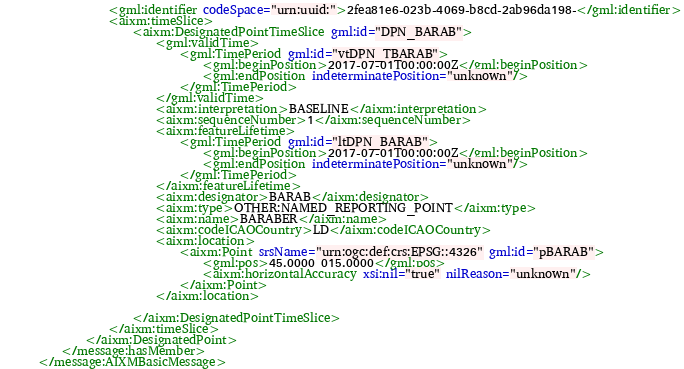Convert code to text. <code><loc_0><loc_0><loc_500><loc_500><_XML_>			<gml:identifier codeSpace="urn:uuid:">2fea81e6-023b-4069-b8cd-2ab96da198-</gml:identifier>
			<aixm:timeSlice>
				<aixm:DesignatedPointTimeSlice gml:id="DPN_BARAB">
					<gml:validTime>
						<gml:TimePeriod gml:id="vtDPN_TBARAB">
							<gml:beginPosition>2017-07-01T00:00:00Z</gml:beginPosition>
							<gml:endPosition indeterminatePosition="unknown"/>
						</gml:TimePeriod>
					</gml:validTime>
					<aixm:interpretation>BASELINE</aixm:interpretation>
					<aixm:sequenceNumber>1</aixm:sequenceNumber>
					<aixm:featureLifetime>
						<gml:TimePeriod gml:id="ltDPN_BARAB">
							<gml:beginPosition>2017-07-01T00:00:00Z</gml:beginPosition>
							<gml:endPosition indeterminatePosition="unknown"/>
						</gml:TimePeriod>
					</aixm:featureLifetime>
					<aixm:designator>BARAB</aixm:designator>
					<aixm:type>OTHER:NAMED_REPORTING_POINT</aixm:type>
					<aixm:name>BARABER</aixm:name>
					<aixm:codeICAOCountry>LD</aixm:codeICAOCountry>
					<aixm:location>
						<aixm:Point srsName="urn:ogc:def:crs:EPSG::4326" gml:id="pBARAB">
							<gml:pos>45.0000 015.0000</gml:pos>
							<aixm:horizontalAccuracy xsi:nil="true" nilReason="unknown"/>
						</aixm:Point>
					</aixm:location>
					
				</aixm:DesignatedPointTimeSlice>
			</aixm:timeSlice>
		</aixm:DesignatedPoint>
	</message:hasMember>
</message:AIXMBasicMessage></code> 